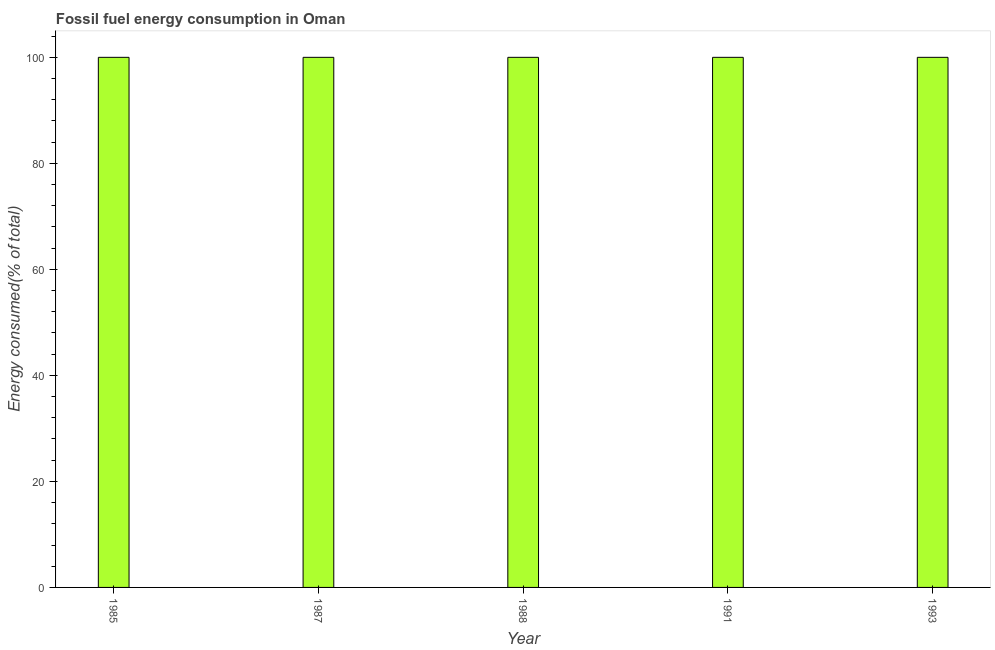Does the graph contain any zero values?
Your answer should be compact. No. What is the title of the graph?
Provide a succinct answer. Fossil fuel energy consumption in Oman. What is the label or title of the X-axis?
Make the answer very short. Year. What is the label or title of the Y-axis?
Provide a short and direct response. Energy consumed(% of total). Across all years, what is the maximum fossil fuel energy consumption?
Make the answer very short. 100. Across all years, what is the minimum fossil fuel energy consumption?
Offer a terse response. 100. In which year was the fossil fuel energy consumption minimum?
Give a very brief answer. 1991. What is the sum of the fossil fuel energy consumption?
Give a very brief answer. 500. What is the average fossil fuel energy consumption per year?
Offer a terse response. 100. What is the median fossil fuel energy consumption?
Provide a succinct answer. 100. In how many years, is the fossil fuel energy consumption greater than 8 %?
Your answer should be compact. 5. Do a majority of the years between 1987 and 1988 (inclusive) have fossil fuel energy consumption greater than 72 %?
Give a very brief answer. Yes. Is the fossil fuel energy consumption in 1991 less than that in 1993?
Your answer should be compact. Yes. Is the difference between the fossil fuel energy consumption in 1988 and 1991 greater than the difference between any two years?
Offer a terse response. Yes. In how many years, is the fossil fuel energy consumption greater than the average fossil fuel energy consumption taken over all years?
Your answer should be very brief. 4. How many years are there in the graph?
Offer a terse response. 5. What is the difference between two consecutive major ticks on the Y-axis?
Offer a very short reply. 20. Are the values on the major ticks of Y-axis written in scientific E-notation?
Give a very brief answer. No. What is the Energy consumed(% of total) in 1988?
Provide a succinct answer. 100. What is the Energy consumed(% of total) of 1991?
Offer a very short reply. 100. What is the difference between the Energy consumed(% of total) in 1985 and 1988?
Make the answer very short. 0. What is the difference between the Energy consumed(% of total) in 1985 and 1991?
Offer a very short reply. 3e-5. What is the difference between the Energy consumed(% of total) in 1985 and 1993?
Offer a terse response. 0. What is the difference between the Energy consumed(% of total) in 1987 and 1988?
Provide a succinct answer. 0. What is the difference between the Energy consumed(% of total) in 1987 and 1991?
Your answer should be compact. 3e-5. What is the difference between the Energy consumed(% of total) in 1988 and 1991?
Your answer should be very brief. 3e-5. What is the difference between the Energy consumed(% of total) in 1988 and 1993?
Provide a short and direct response. 0. What is the difference between the Energy consumed(% of total) in 1991 and 1993?
Provide a short and direct response. -3e-5. What is the ratio of the Energy consumed(% of total) in 1985 to that in 1987?
Make the answer very short. 1. What is the ratio of the Energy consumed(% of total) in 1985 to that in 1988?
Your response must be concise. 1. What is the ratio of the Energy consumed(% of total) in 1988 to that in 1991?
Keep it short and to the point. 1. What is the ratio of the Energy consumed(% of total) in 1988 to that in 1993?
Your answer should be very brief. 1. 